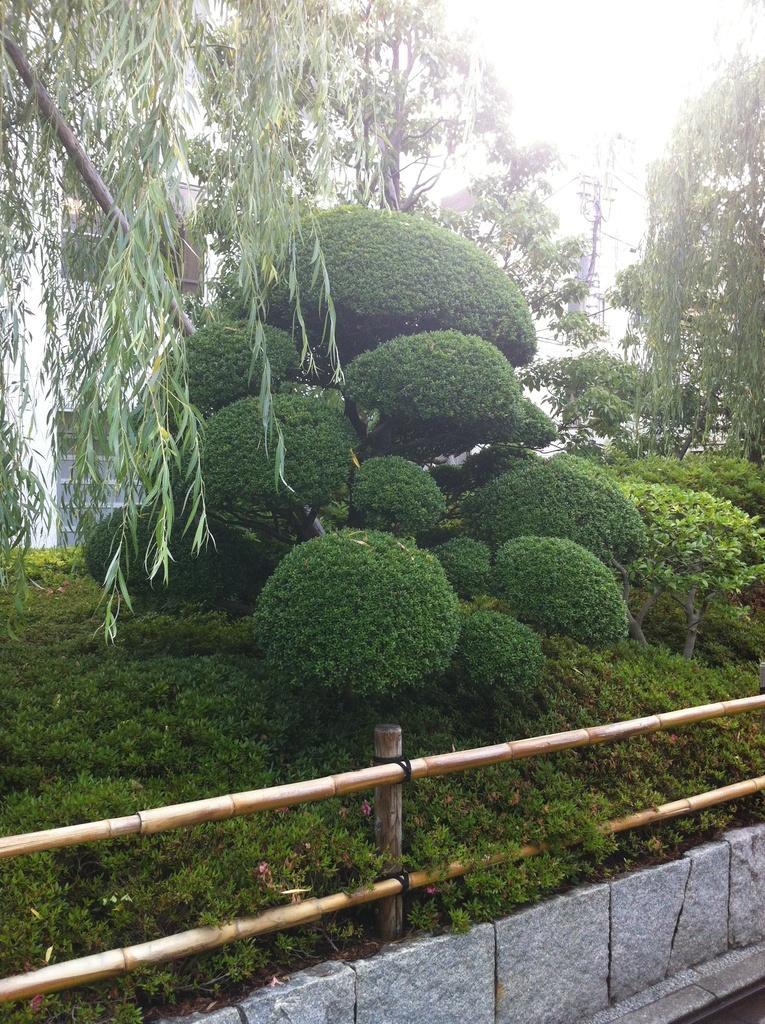Describe this image in one or two sentences. In this picture we can see a fence from left to right. There are a few plants, trees and a building is visible in the background. 